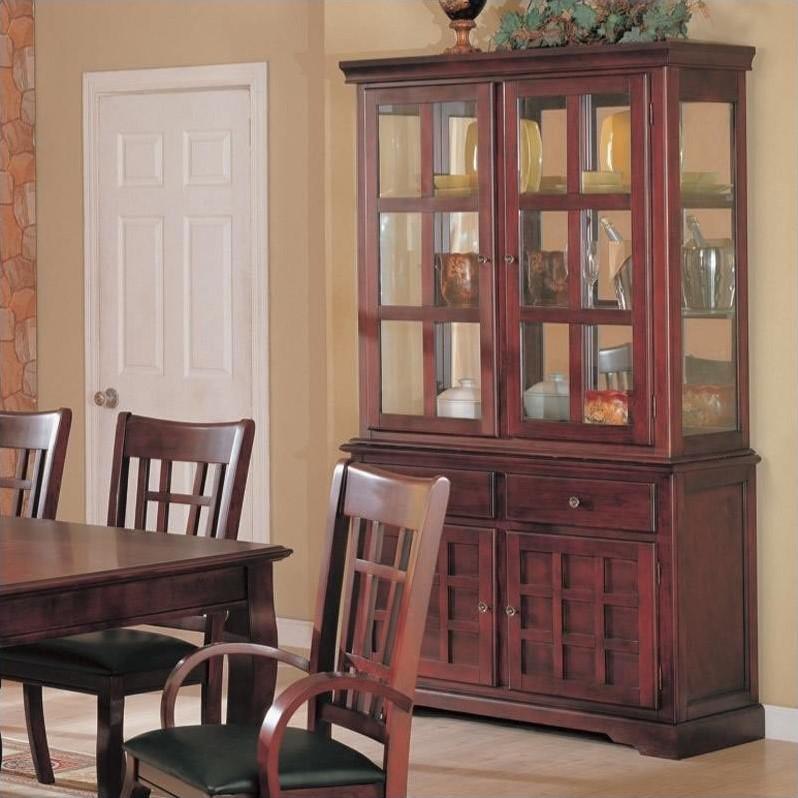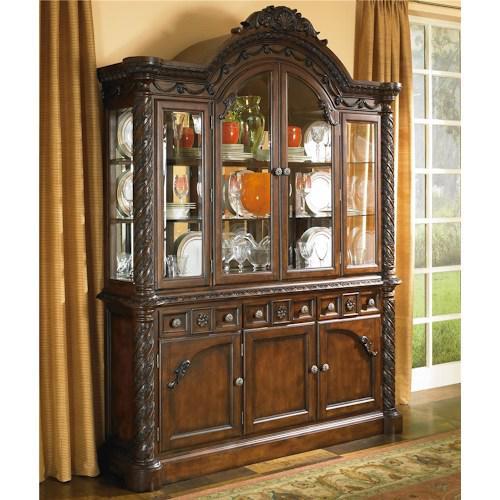The first image is the image on the left, the second image is the image on the right. Given the left and right images, does the statement "There are two cabinets in one of the images." hold true? Answer yes or no. No. 